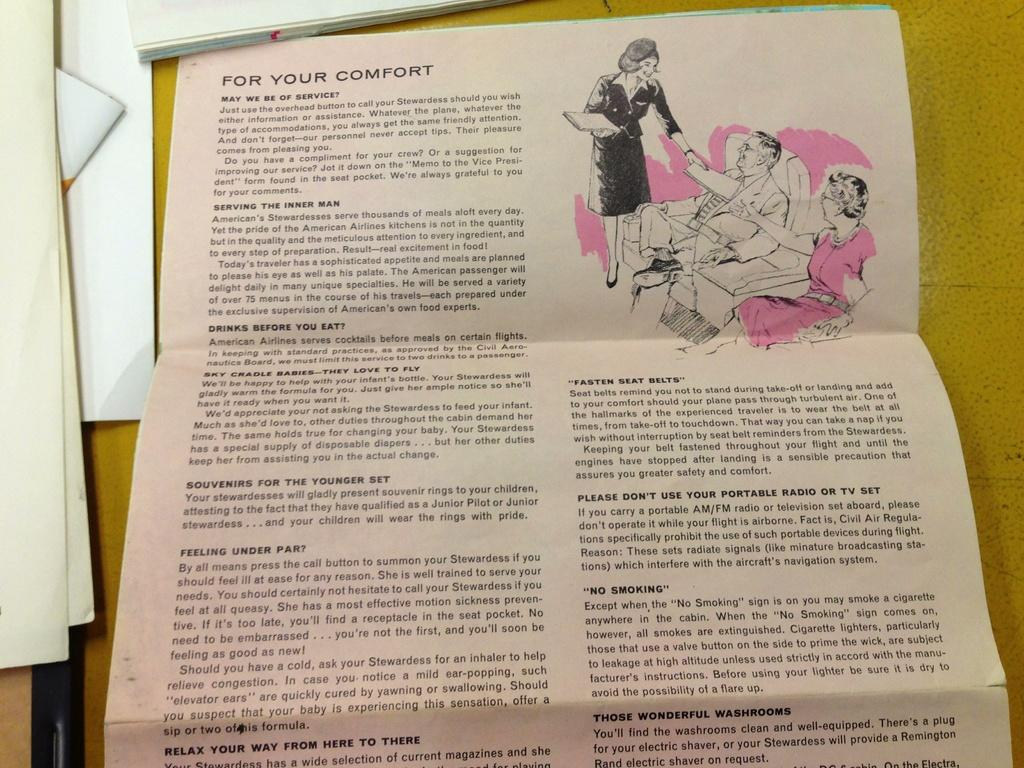What is depicted on the paper in the image? There is a paper with a picture of three people in the image. What else can be seen on the paper besides the picture? The paper has letters on it. Where are the papers located in the image? The papers are placed on a table. What type of soup is being served at the meeting in the image? There is no meeting or soup present in the image; it only features a paper with a picture of three people and letters on it. 